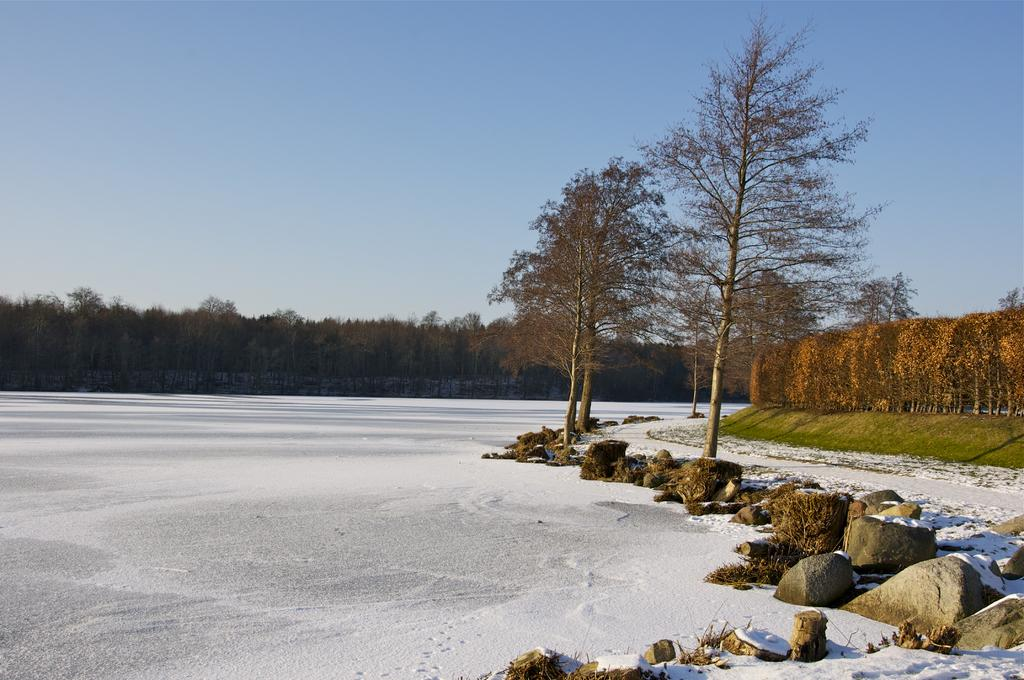What type of weather is depicted in the image? The image shows snow on the ground, indicating cold weather. What objects are covered with snow on the ground? Rocks covered with snow are present on the ground. What type of vegetation is visible in the image? There are many trees in the image. What is visible at the top of the image? The sky is visible at the top of the image. What type of pets can be seen playing with a fire in the image? There is no fire or pets present in the image. What type of gun is visible in the image? There is no gun present in the image. 